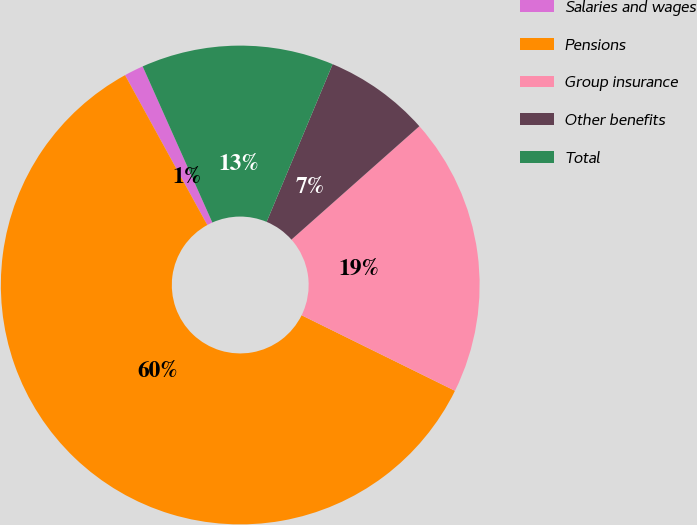<chart> <loc_0><loc_0><loc_500><loc_500><pie_chart><fcel>Salaries and wages<fcel>Pensions<fcel>Group insurance<fcel>Other benefits<fcel>Total<nl><fcel>1.31%<fcel>59.73%<fcel>18.83%<fcel>7.15%<fcel>12.99%<nl></chart> 